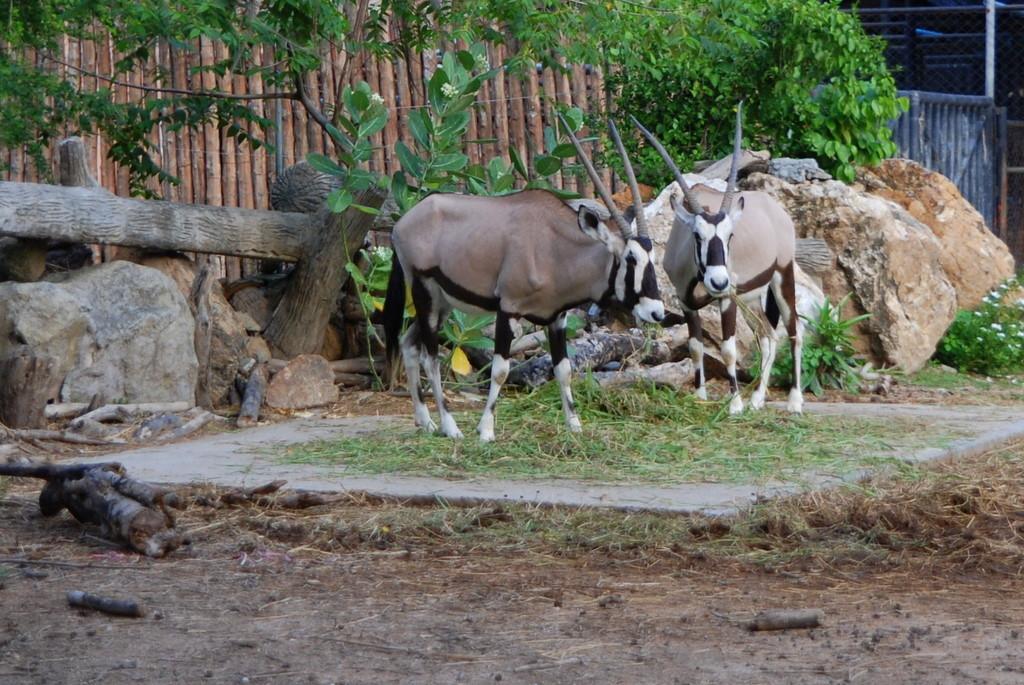How would you summarize this image in a sentence or two? In this picture I can see couple of gemsbok and I can see trees, few rocks and a tree bark and few sticks on the ground and I can see grass and few plants with flowers. 